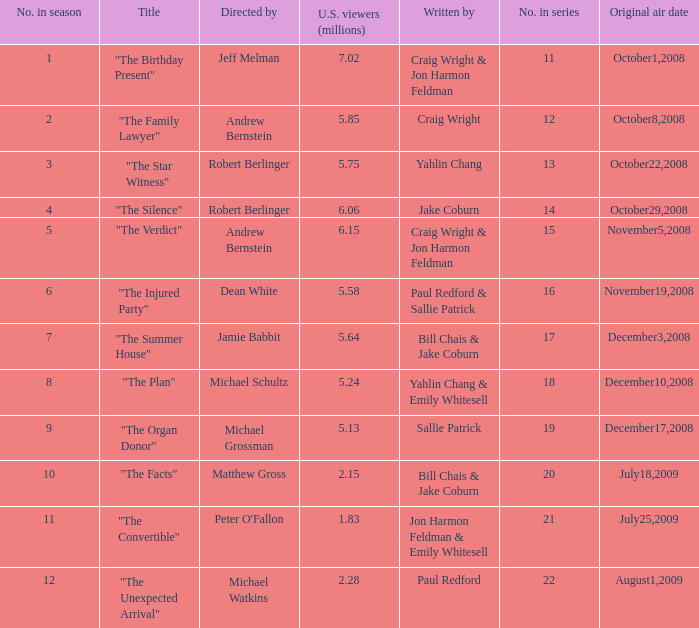What is the original air date of the episode directed by Jeff Melman? October1,2008. 